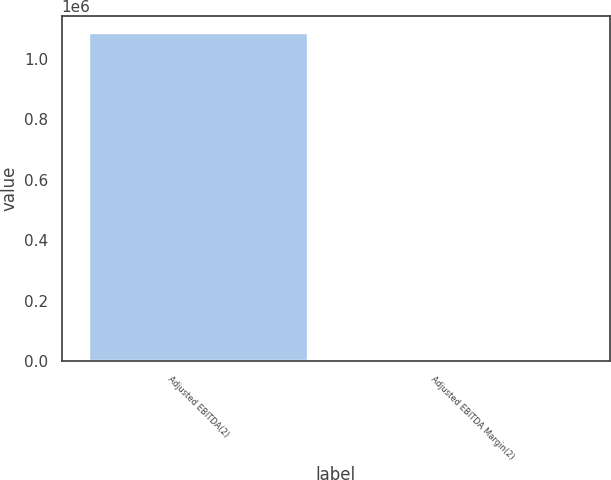Convert chart. <chart><loc_0><loc_0><loc_500><loc_500><bar_chart><fcel>Adjusted EBITDA(2)<fcel>Adjusted EBITDA Margin(2)<nl><fcel>1.08729e+06<fcel>31<nl></chart> 